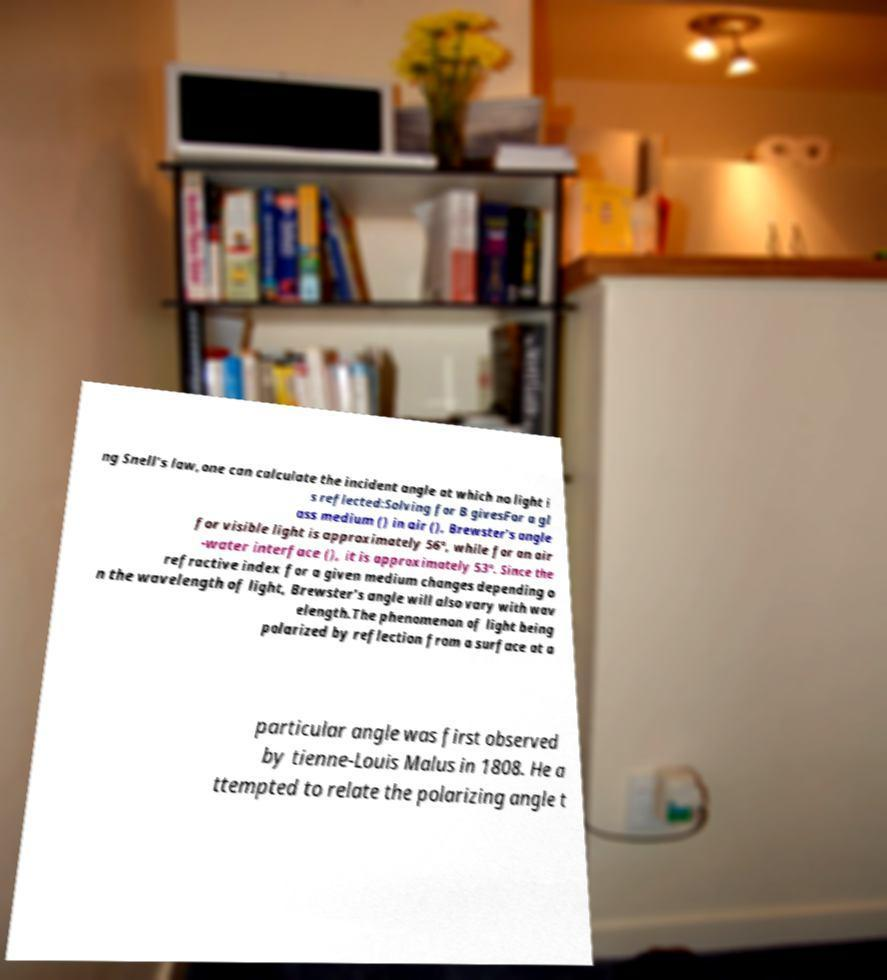Could you extract and type out the text from this image? ng Snell's law,one can calculate the incident angle at which no light i s reflected:Solving for B givesFor a gl ass medium () in air (), Brewster's angle for visible light is approximately 56°, while for an air -water interface (), it is approximately 53°. Since the refractive index for a given medium changes depending o n the wavelength of light, Brewster's angle will also vary with wav elength.The phenomenon of light being polarized by reflection from a surface at a particular angle was first observed by tienne-Louis Malus in 1808. He a ttempted to relate the polarizing angle t 